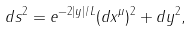<formula> <loc_0><loc_0><loc_500><loc_500>d s ^ { 2 } = e ^ { - 2 | y | / L } ( d x ^ { \mu } ) ^ { 2 } + d y ^ { 2 } ,</formula> 